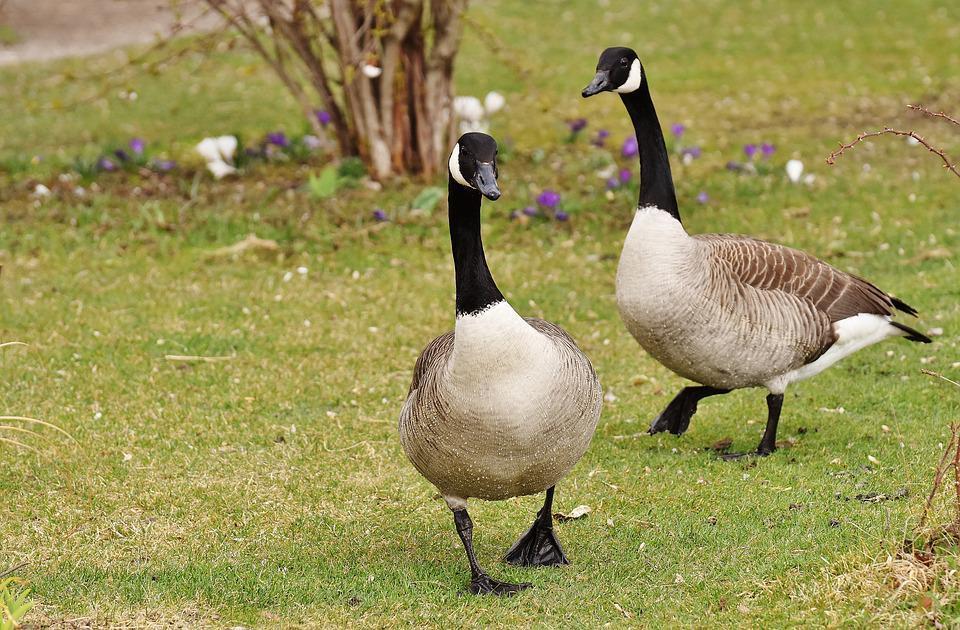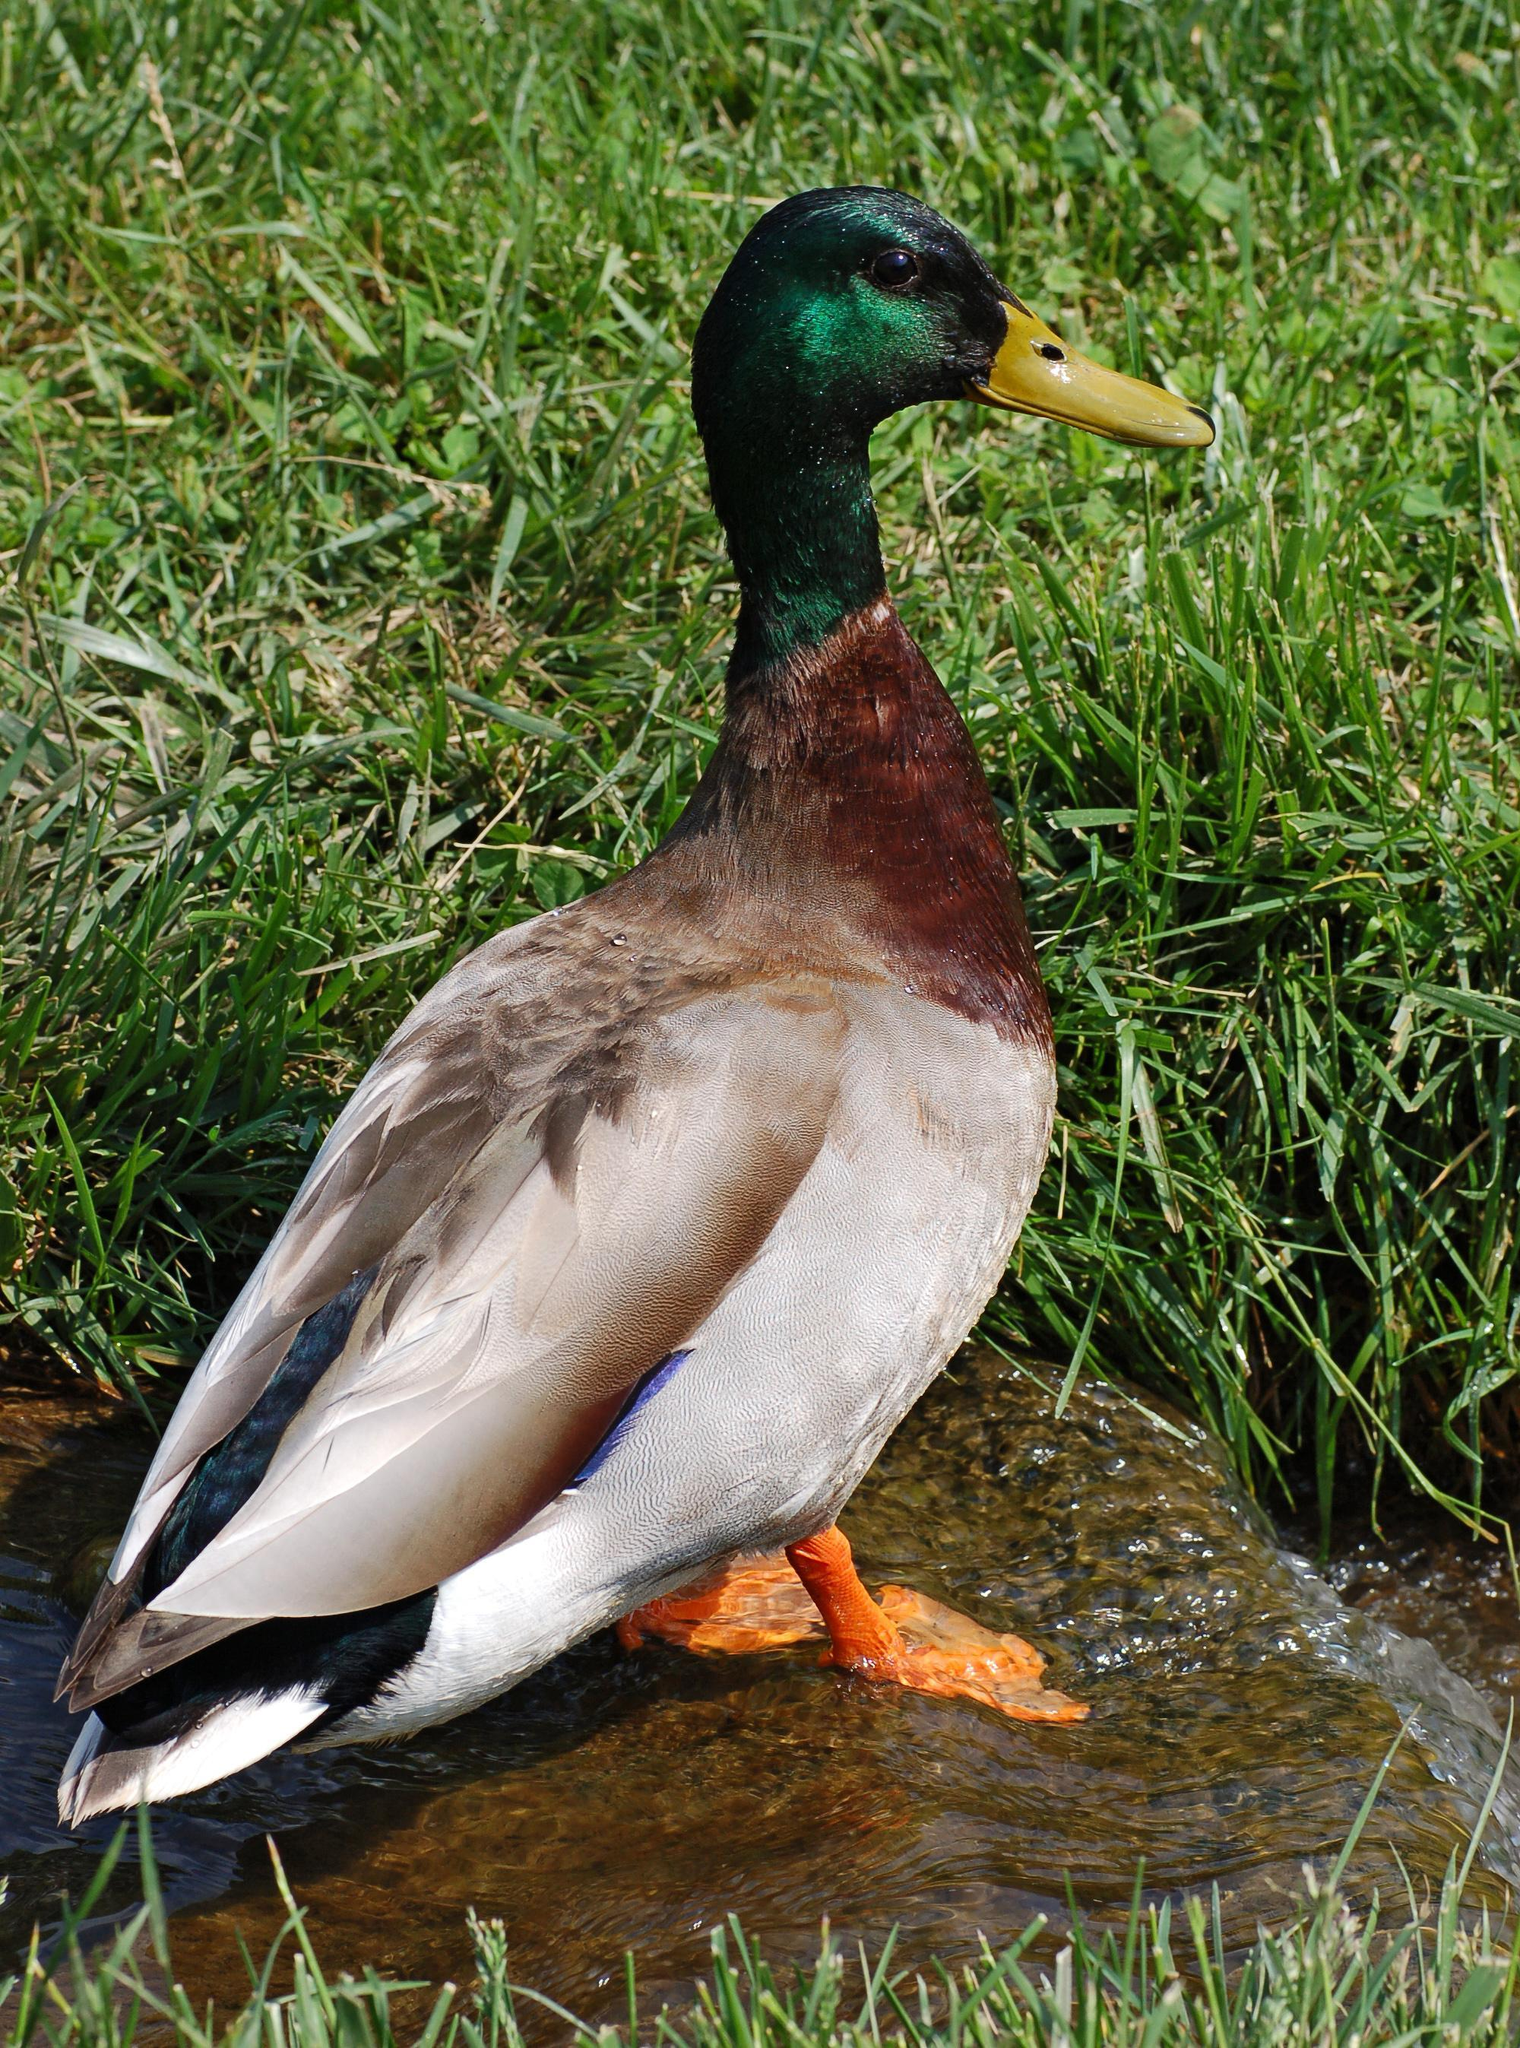The first image is the image on the left, the second image is the image on the right. Assess this claim about the two images: "There are two geese". Correct or not? Answer yes or no. No. 